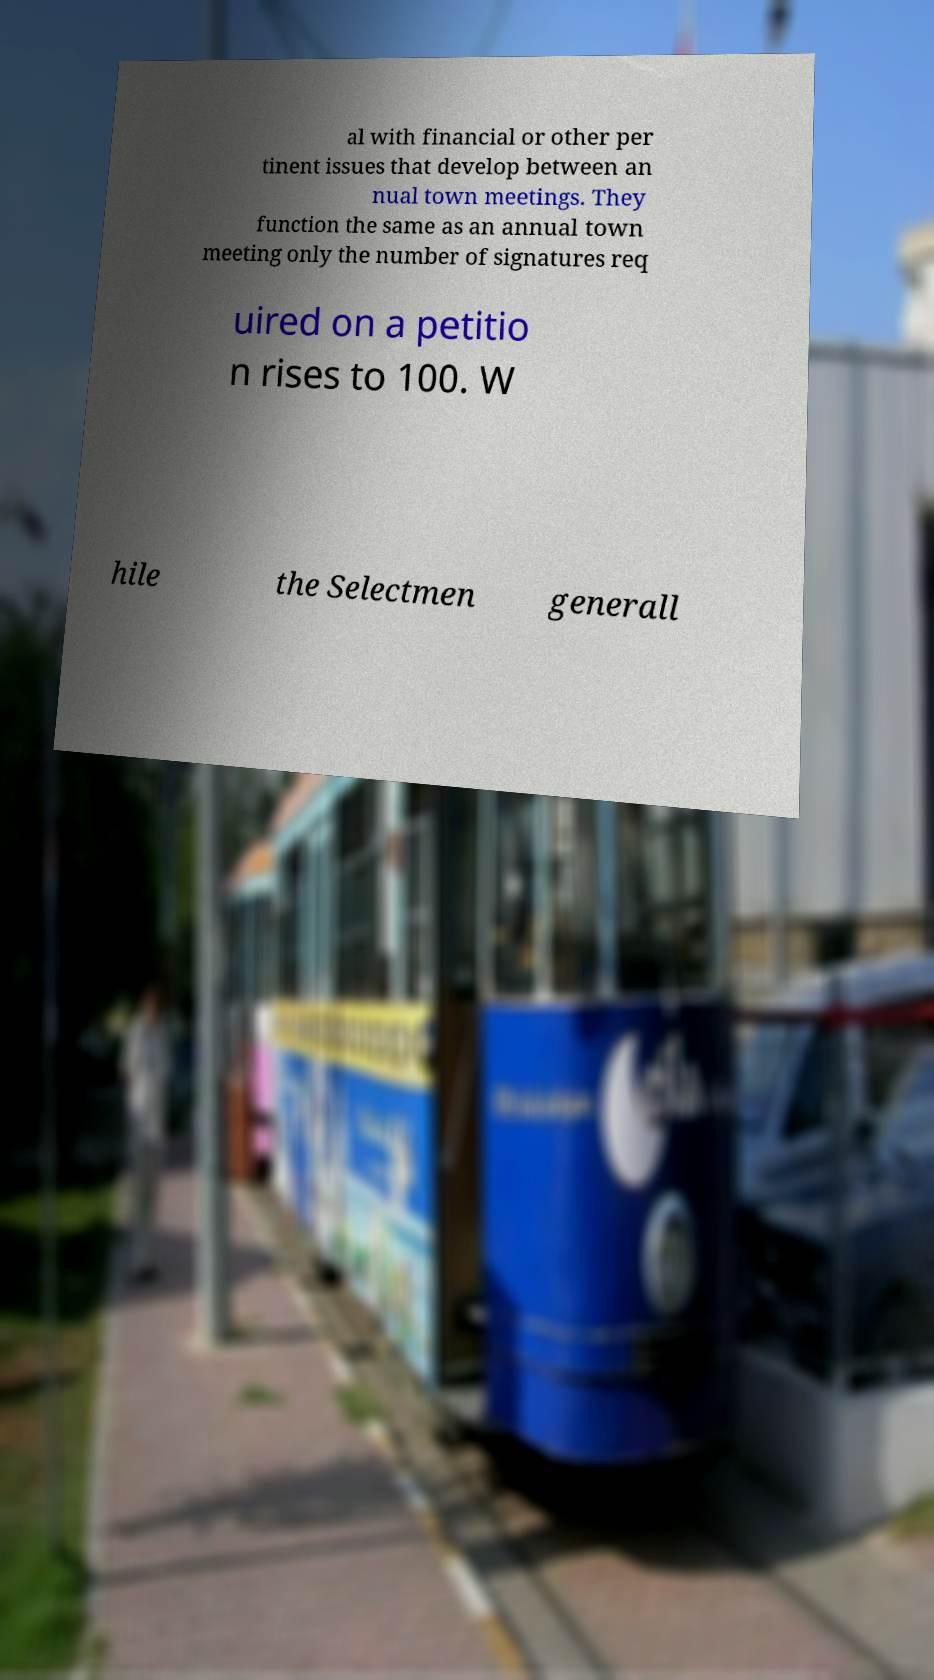Can you accurately transcribe the text from the provided image for me? al with financial or other per tinent issues that develop between an nual town meetings. They function the same as an annual town meeting only the number of signatures req uired on a petitio n rises to 100. W hile the Selectmen generall 